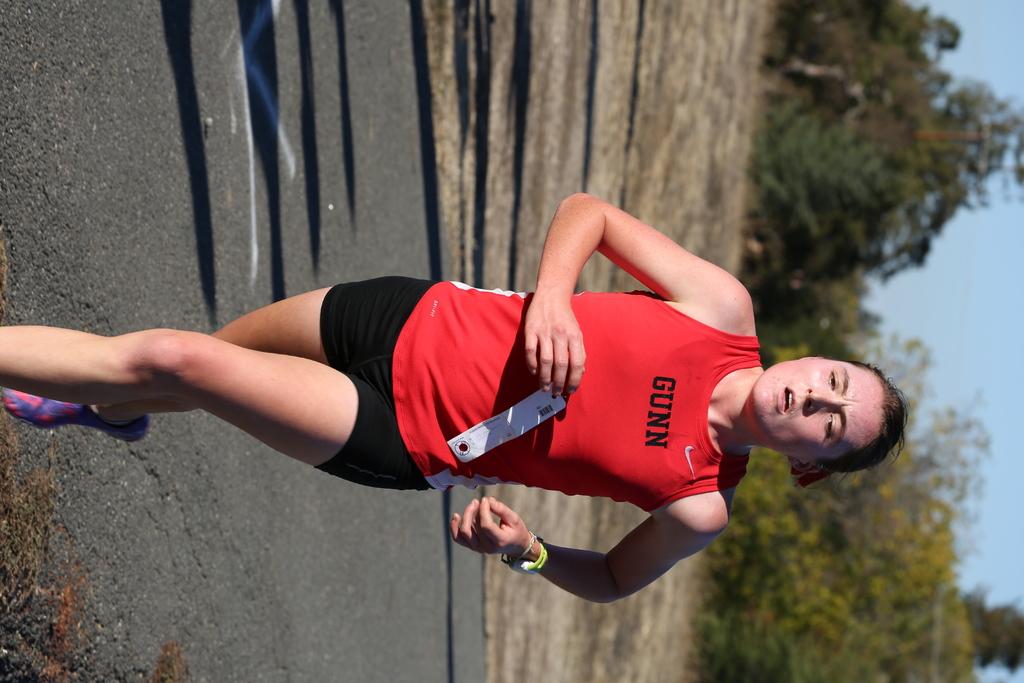What is the name on the runners t-shirt?
Give a very brief answer. Gunn. What color is the word "gunn" on her shirt?
Offer a terse response. Black. 